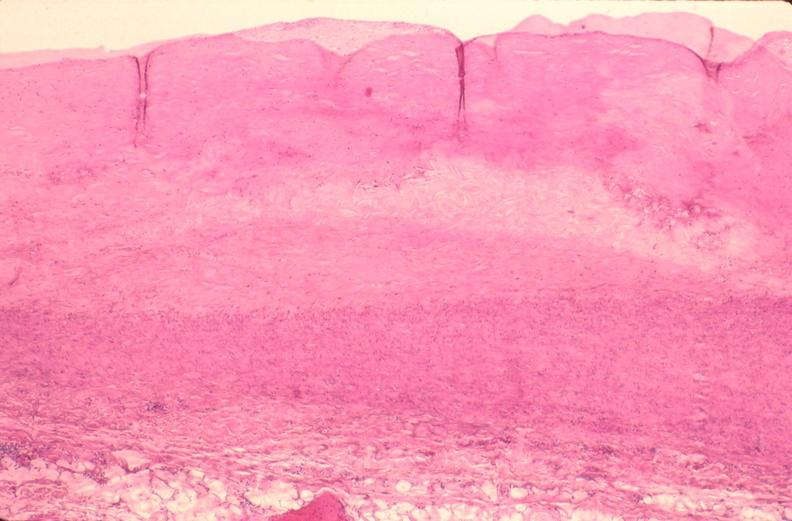how does this image show pulmonary artery atherosclerosis in patient?
Answer the question using a single word or phrase. With hypertension 